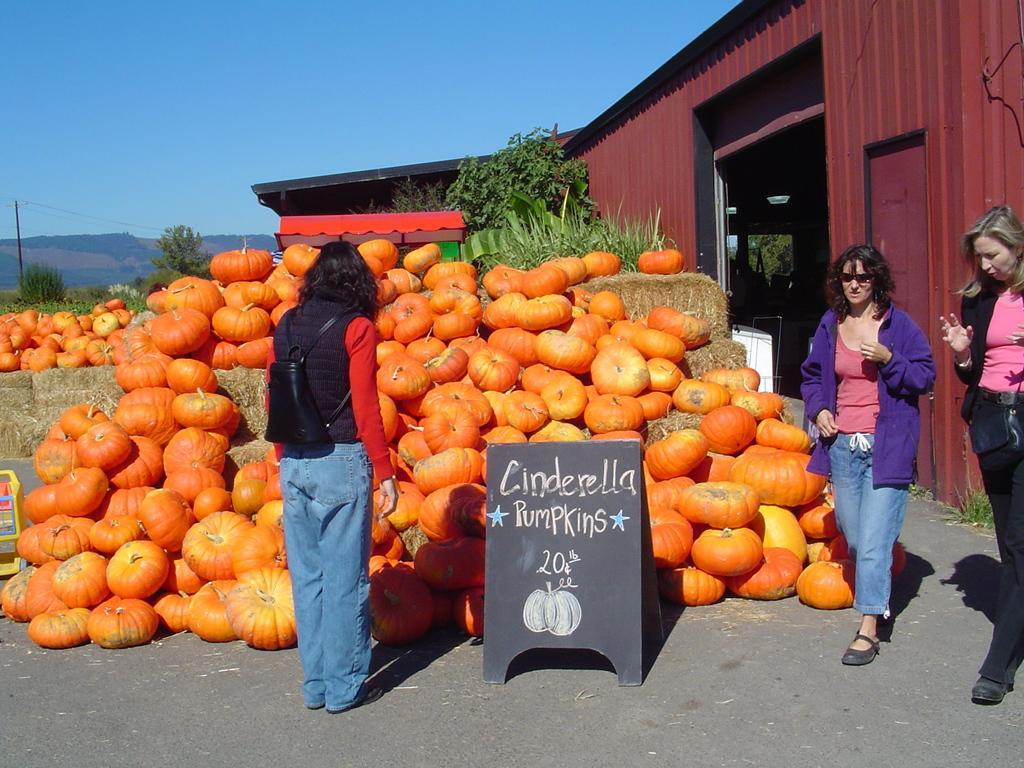In one or two sentences, can you explain what this image depicts? In this image we can see a person and a board with text. Behind the person we can see a group of pumpkins and few trees. On the right side, we can see a shed and two persons walking. On the left side, we can see mountains, trees and plants. At the top we can see the sky. 